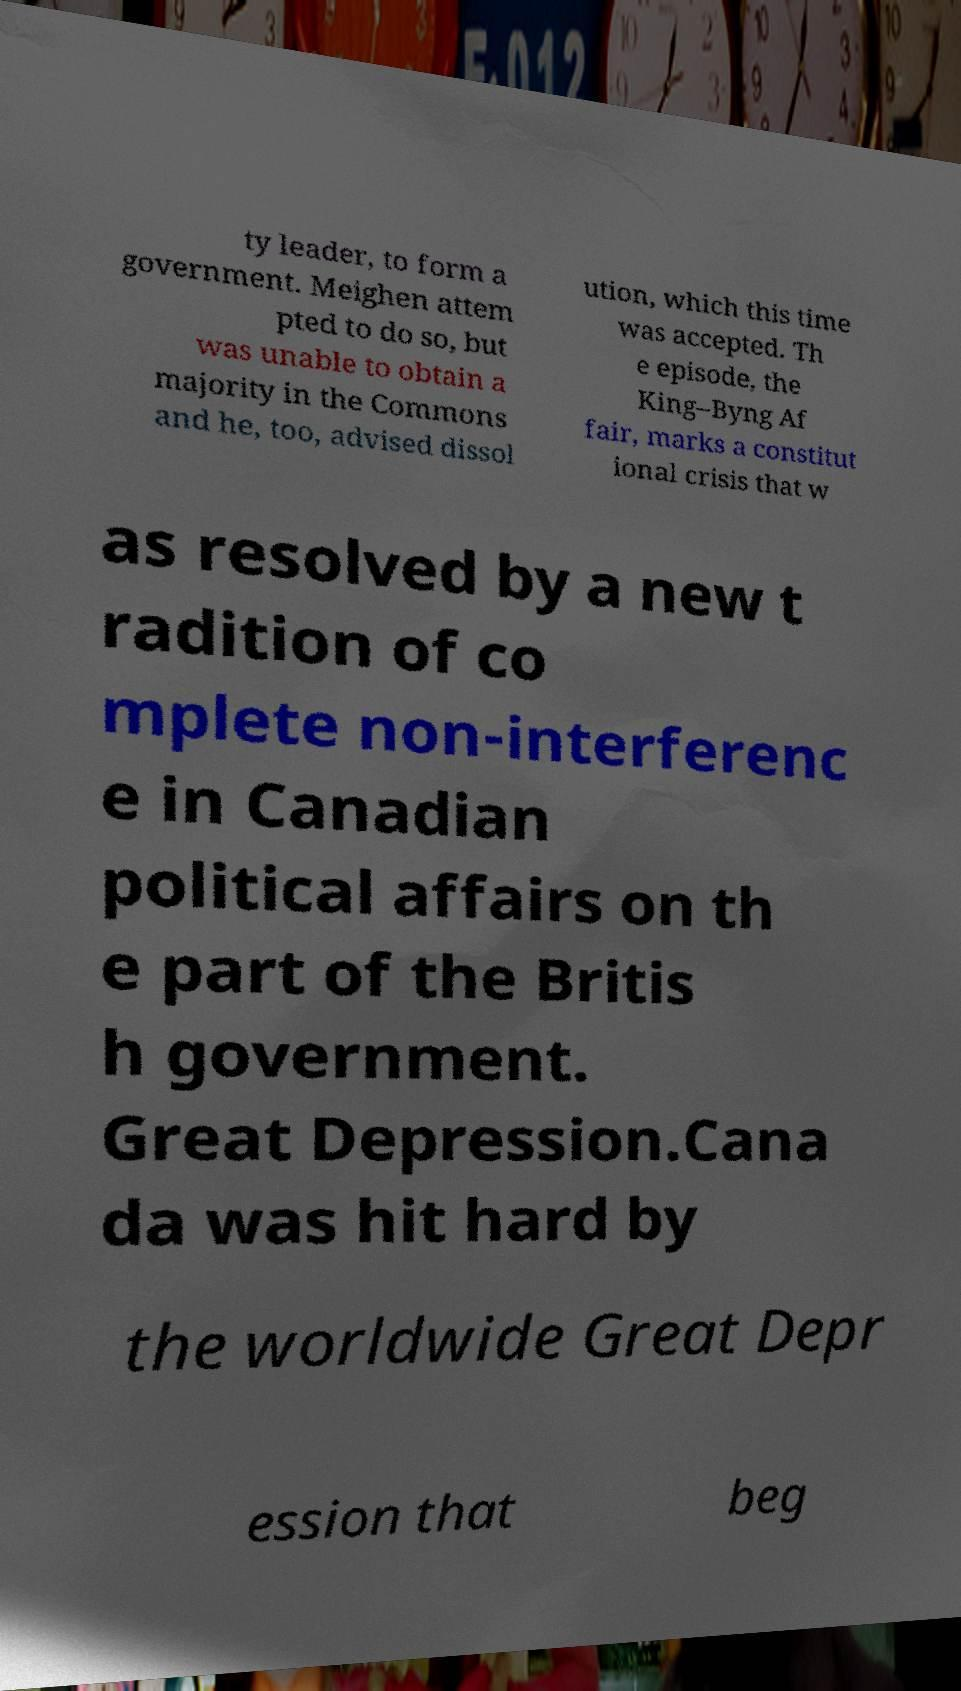Please identify and transcribe the text found in this image. ty leader, to form a government. Meighen attem pted to do so, but was unable to obtain a majority in the Commons and he, too, advised dissol ution, which this time was accepted. Th e episode, the King–Byng Af fair, marks a constitut ional crisis that w as resolved by a new t radition of co mplete non-interferenc e in Canadian political affairs on th e part of the Britis h government. Great Depression.Cana da was hit hard by the worldwide Great Depr ession that beg 